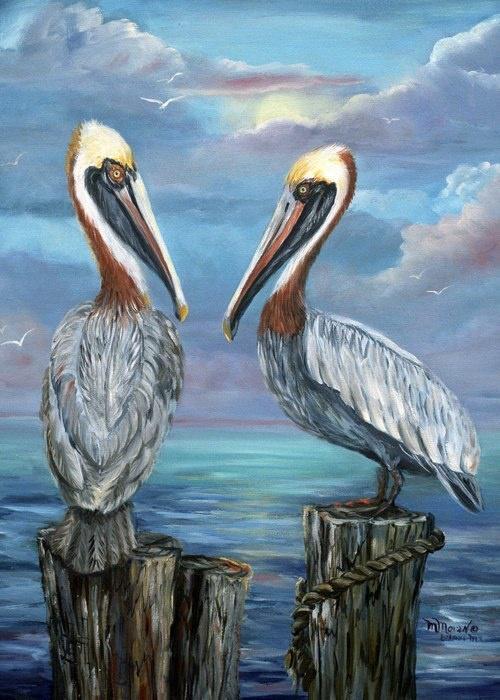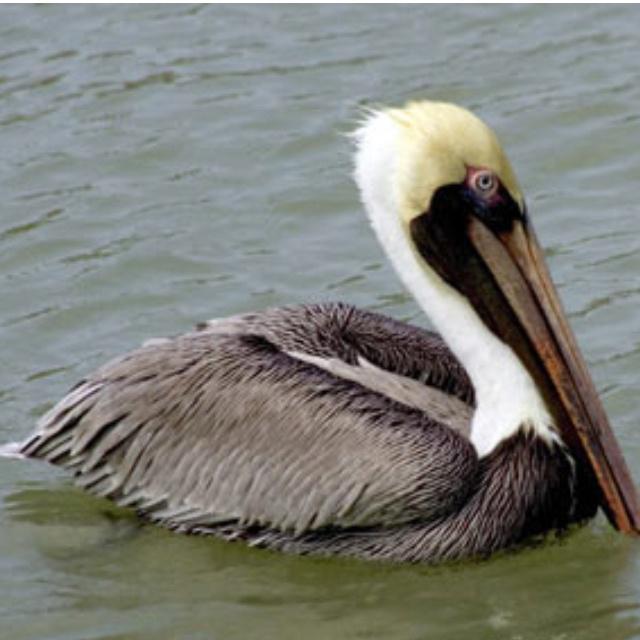The first image is the image on the left, the second image is the image on the right. Considering the images on both sides, is "A bird is sitting on water." valid? Answer yes or no. Yes. 